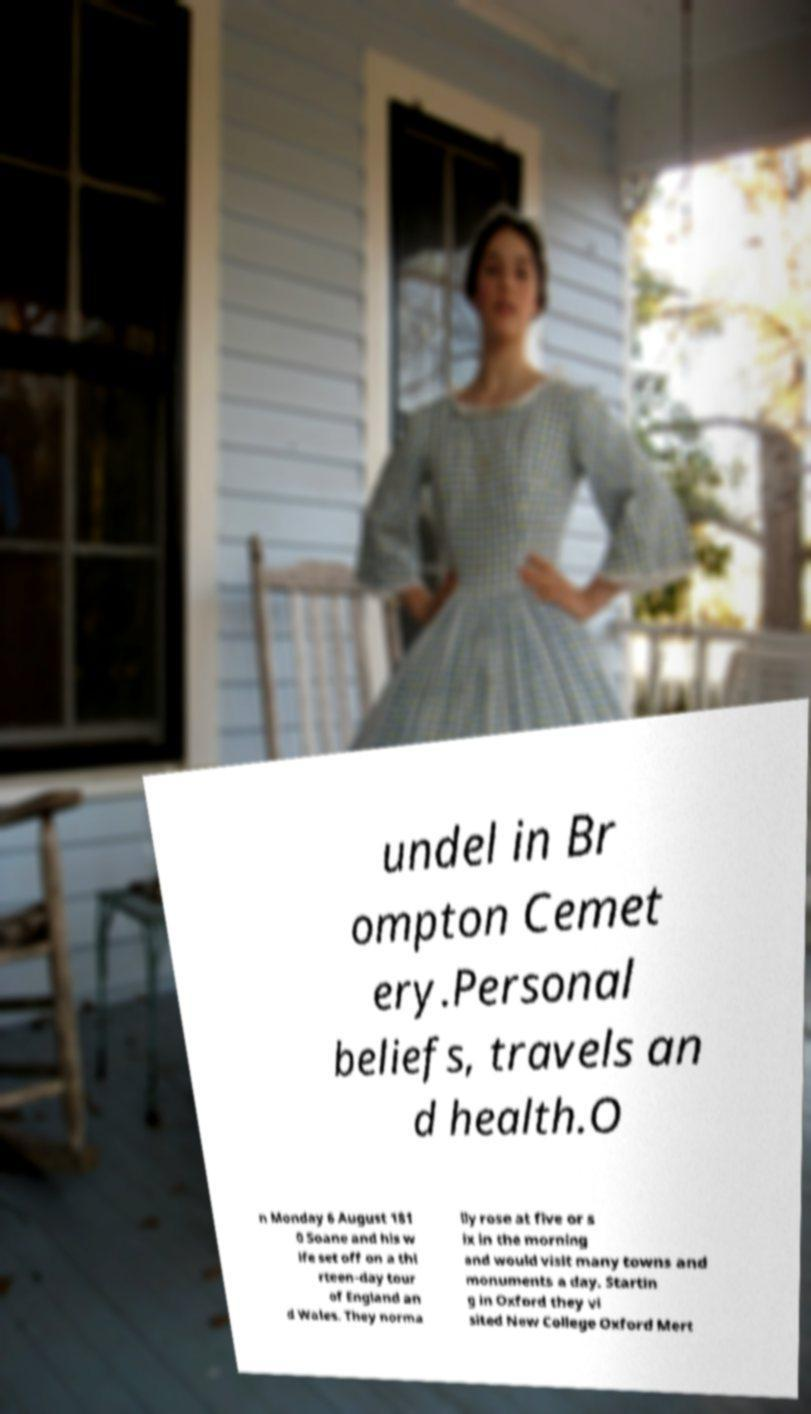For documentation purposes, I need the text within this image transcribed. Could you provide that? undel in Br ompton Cemet ery.Personal beliefs, travels an d health.O n Monday 6 August 181 0 Soane and his w ife set off on a thi rteen-day tour of England an d Wales. They norma lly rose at five or s ix in the morning and would visit many towns and monuments a day. Startin g in Oxford they vi sited New College Oxford Mert 